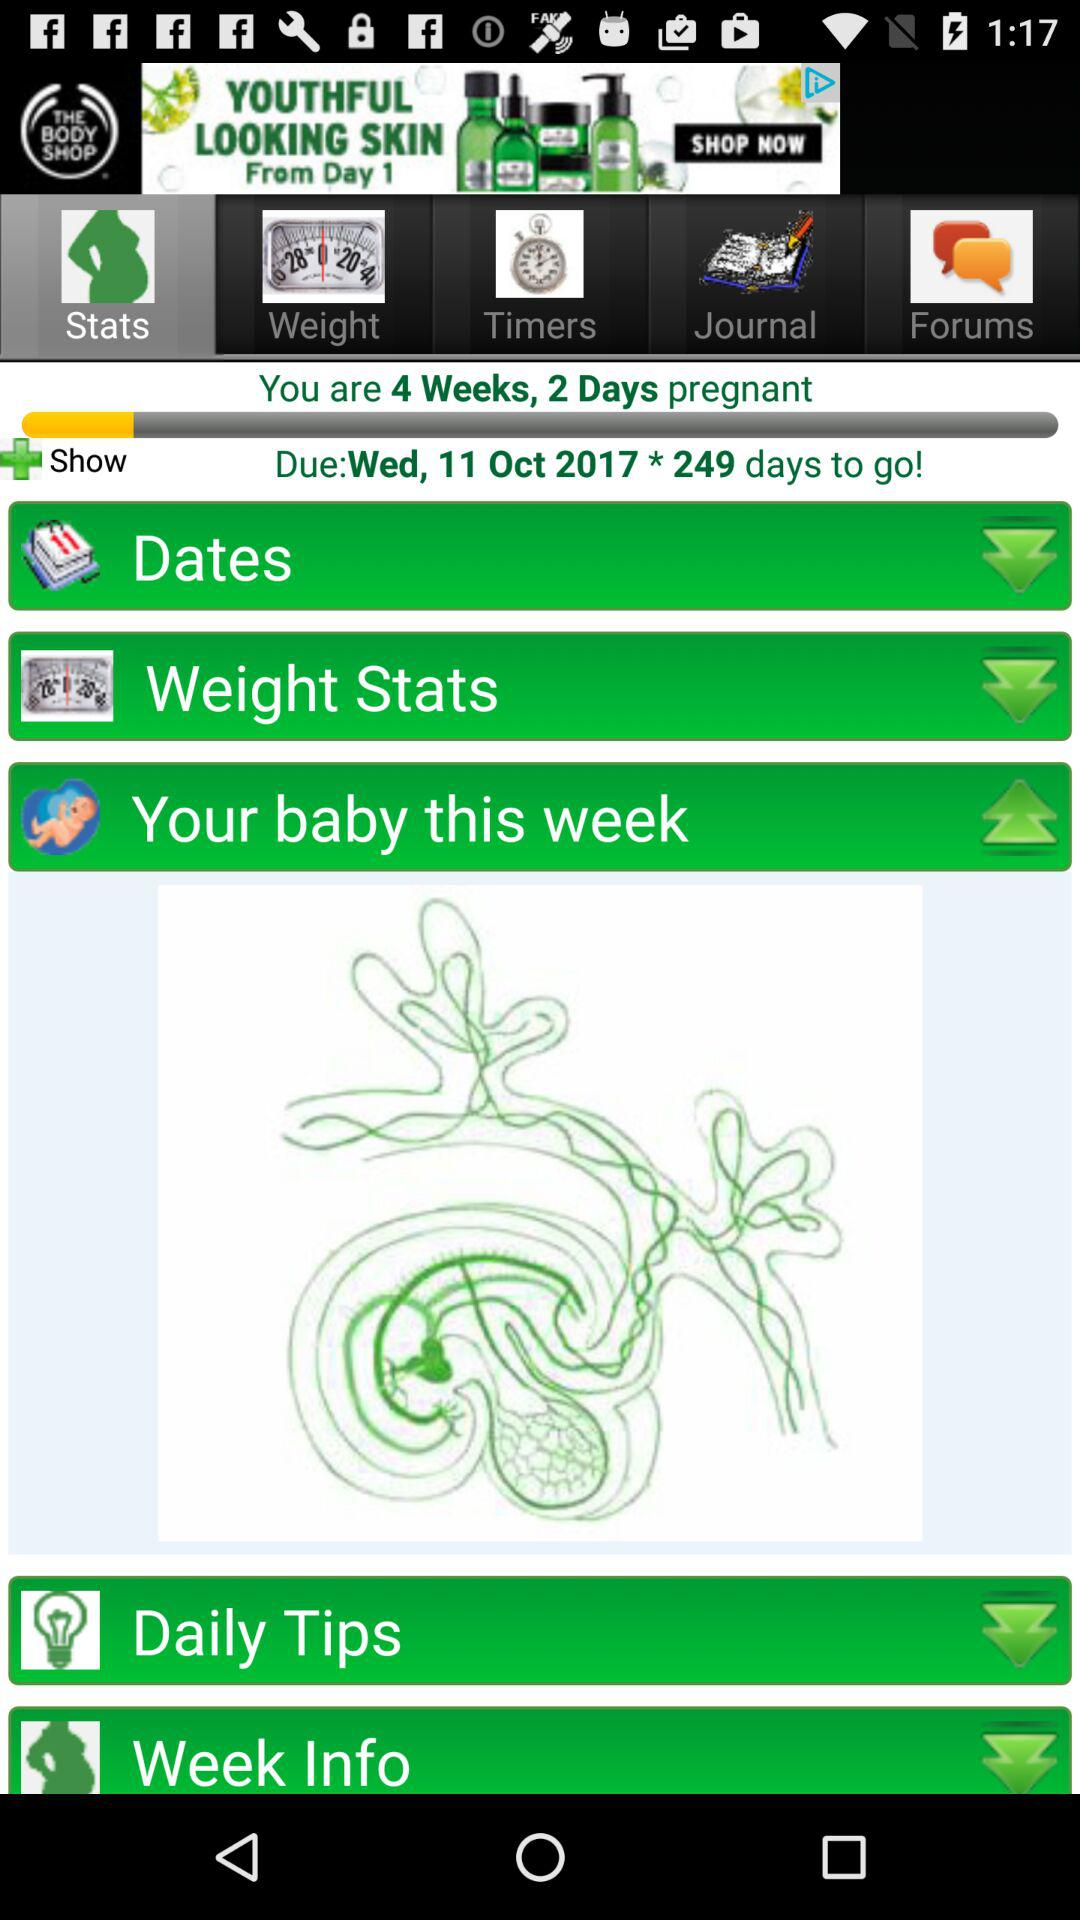How many days am I pregnant? You are 2 days pregnant. 